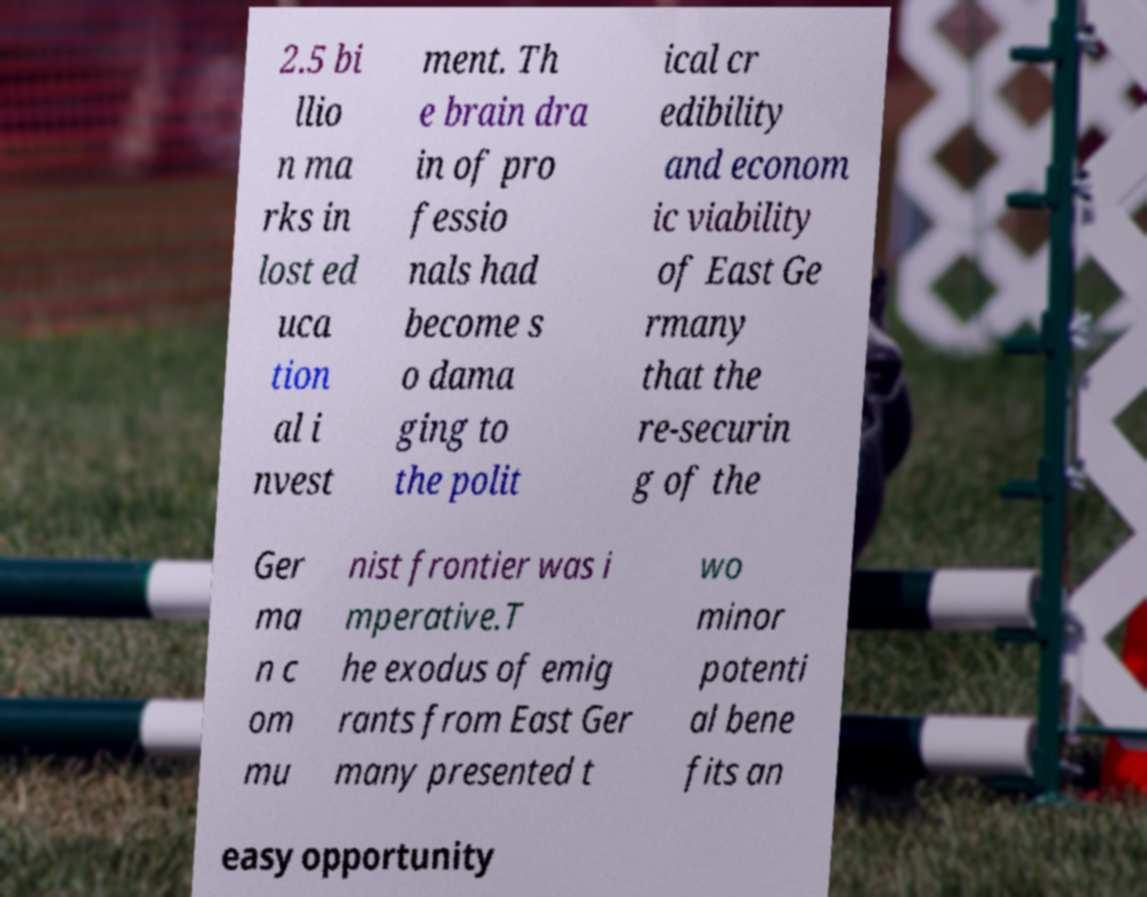Please read and relay the text visible in this image. What does it say? 2.5 bi llio n ma rks in lost ed uca tion al i nvest ment. Th e brain dra in of pro fessio nals had become s o dama ging to the polit ical cr edibility and econom ic viability of East Ge rmany that the re-securin g of the Ger ma n c om mu nist frontier was i mperative.T he exodus of emig rants from East Ger many presented t wo minor potenti al bene fits an easy opportunity 